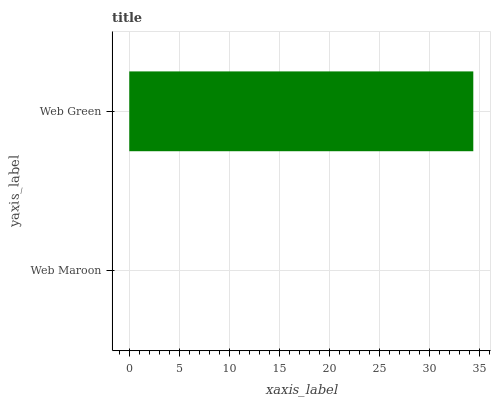Is Web Maroon the minimum?
Answer yes or no. Yes. Is Web Green the maximum?
Answer yes or no. Yes. Is Web Green the minimum?
Answer yes or no. No. Is Web Green greater than Web Maroon?
Answer yes or no. Yes. Is Web Maroon less than Web Green?
Answer yes or no. Yes. Is Web Maroon greater than Web Green?
Answer yes or no. No. Is Web Green less than Web Maroon?
Answer yes or no. No. Is Web Green the high median?
Answer yes or no. Yes. Is Web Maroon the low median?
Answer yes or no. Yes. Is Web Maroon the high median?
Answer yes or no. No. Is Web Green the low median?
Answer yes or no. No. 